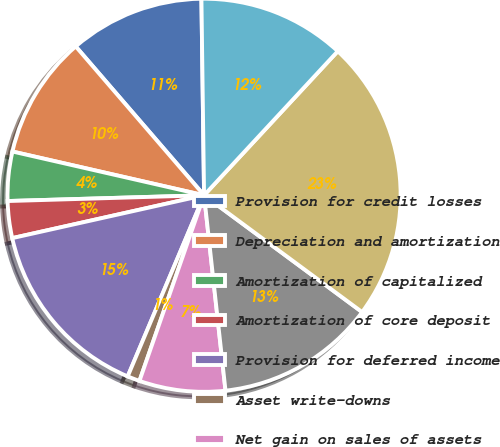<chart> <loc_0><loc_0><loc_500><loc_500><pie_chart><fcel>Provision for credit losses<fcel>Depreciation and amortization<fcel>Amortization of capitalized<fcel>Amortization of core deposit<fcel>Provision for deferred income<fcel>Asset write-downs<fcel>Net gain on sales of assets<fcel>Net change in loans originated<fcel>Available for sale<fcel>Other<nl><fcel>11.11%<fcel>10.1%<fcel>4.04%<fcel>3.03%<fcel>15.15%<fcel>1.02%<fcel>7.07%<fcel>13.13%<fcel>23.22%<fcel>12.12%<nl></chart> 